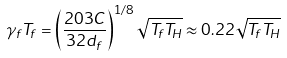<formula> <loc_0><loc_0><loc_500><loc_500>\gamma _ { f } T _ { f } = \left ( \frac { 2 0 3 C } { 3 2 d _ { f } } \right ) ^ { 1 / 8 } \sqrt { T _ { f } T _ { H } } \approx 0 . 2 2 \sqrt { T _ { f } T _ { H } }</formula> 